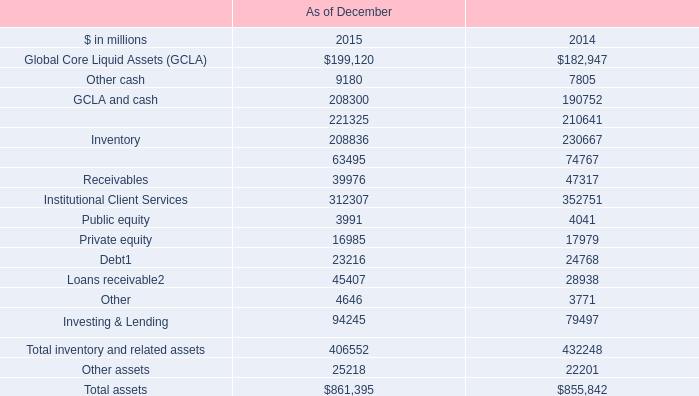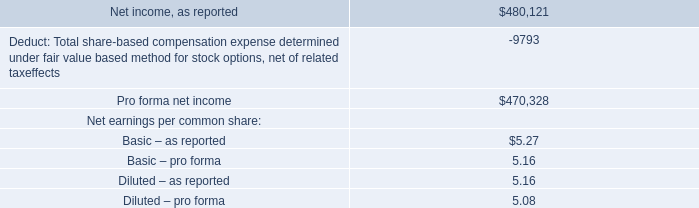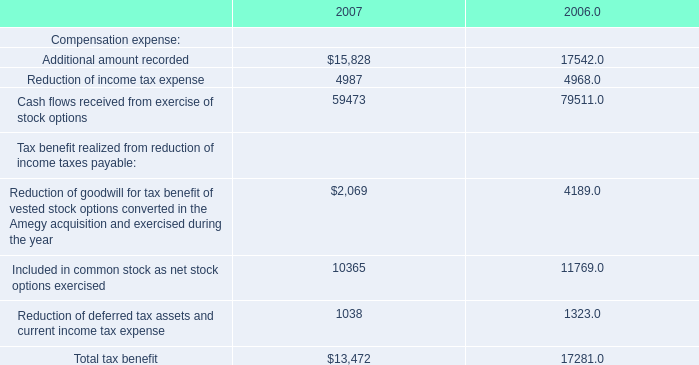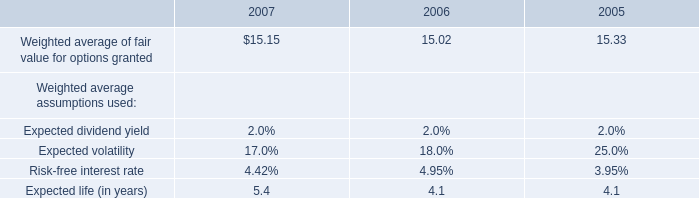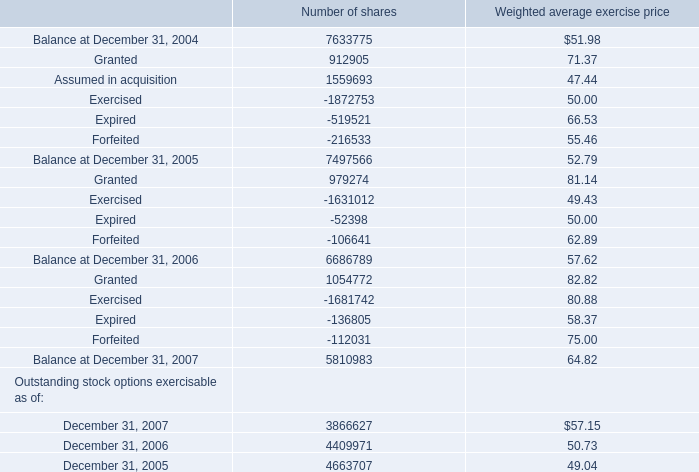When is Granted for number of shares the largest? 
Answer: 2007. 